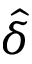<formula> <loc_0><loc_0><loc_500><loc_500>\hat { \delta }</formula> 